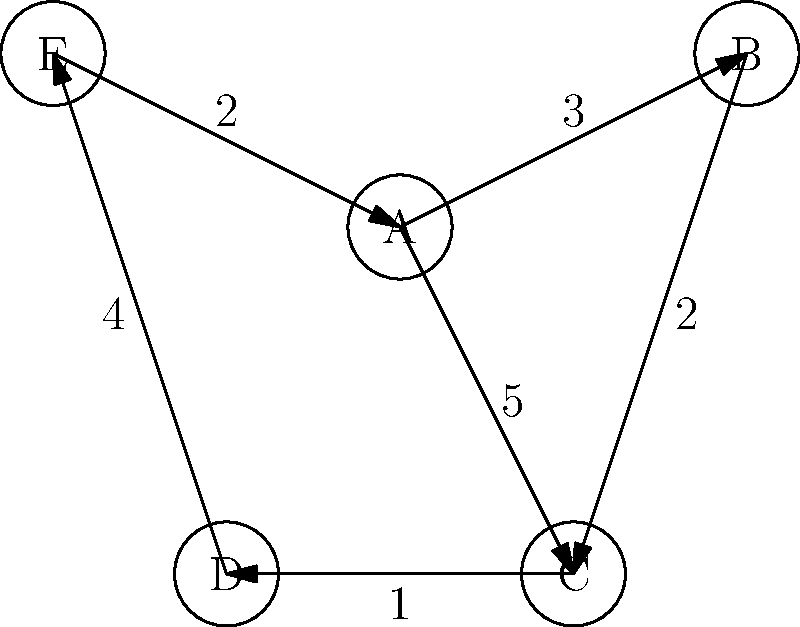In the directed graph shown, nodes represent correctional facilities and edges represent transportation routes between them. The numbers on the edges indicate the time (in hours) required for inmate transfer. What is the minimum time required to transfer an inmate from facility A to facility D? To find the minimum time required to transfer an inmate from facility A to facility D, we need to consider all possible paths and their total times:

1. Path A → B → C → D:
   Time = 3 + 2 + 1 = 6 hours

2. Path A → C → D:
   Time = 5 + 1 = 6 hours

3. Path A → E → D:
   There is no direct path from E to D, so this route is not possible.

We can see that there are two paths with the same minimum time of 6 hours. Both paths A → B → C → D and A → C → D are equally efficient in terms of time.

It's worth noting that in real-world scenarios, other factors such as security concerns, vehicle availability, and inmate classification might influence the choice between these two routes. However, based solely on the time factor given in the graph, both routes are optimal.
Answer: 6 hours 